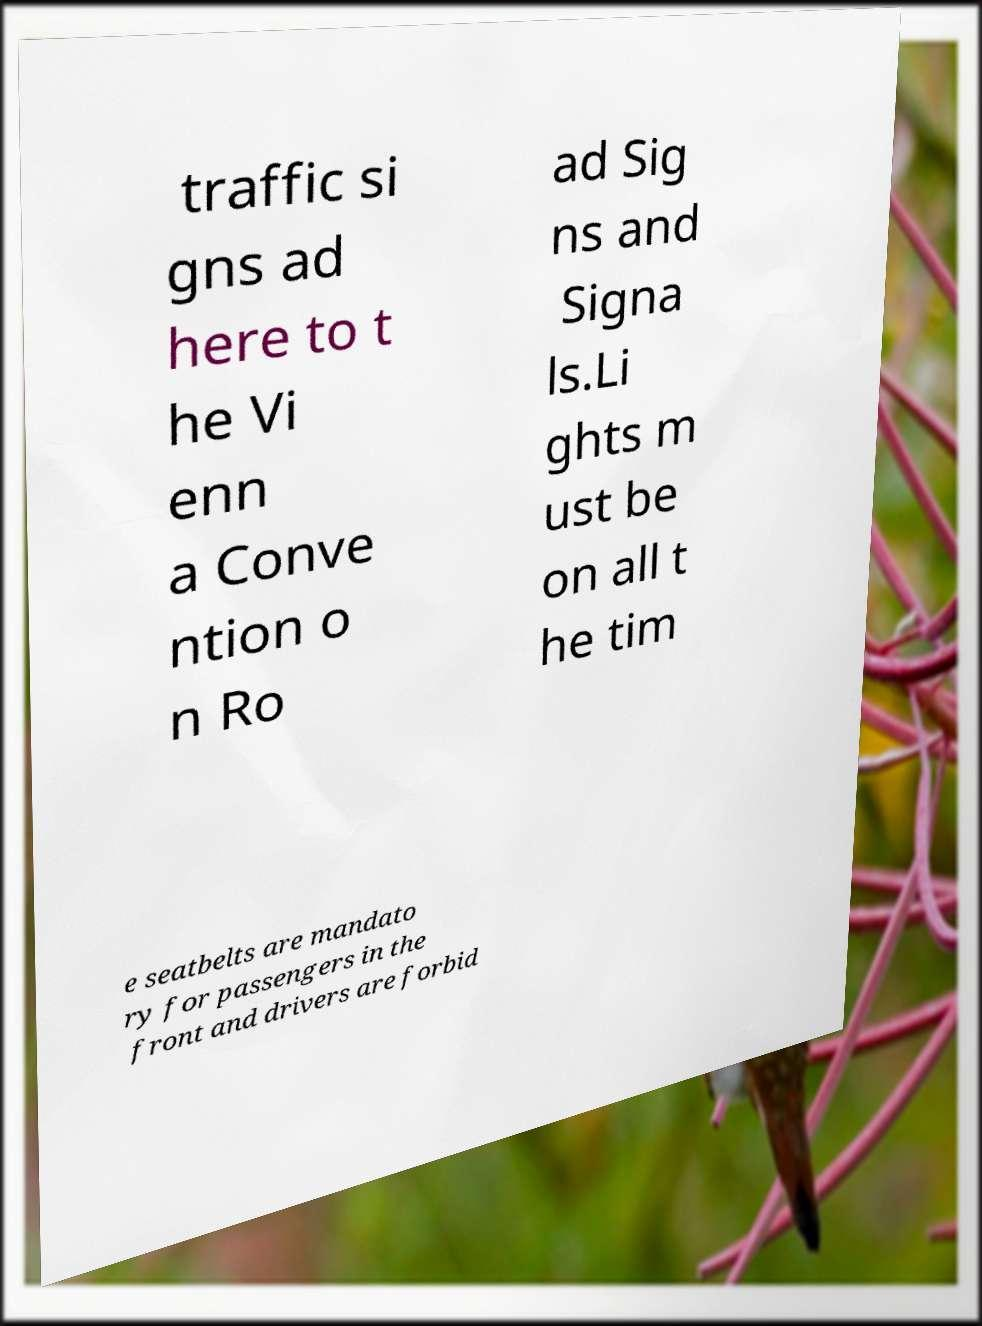Could you assist in decoding the text presented in this image and type it out clearly? traffic si gns ad here to t he Vi enn a Conve ntion o n Ro ad Sig ns and Signa ls.Li ghts m ust be on all t he tim e seatbelts are mandato ry for passengers in the front and drivers are forbid 